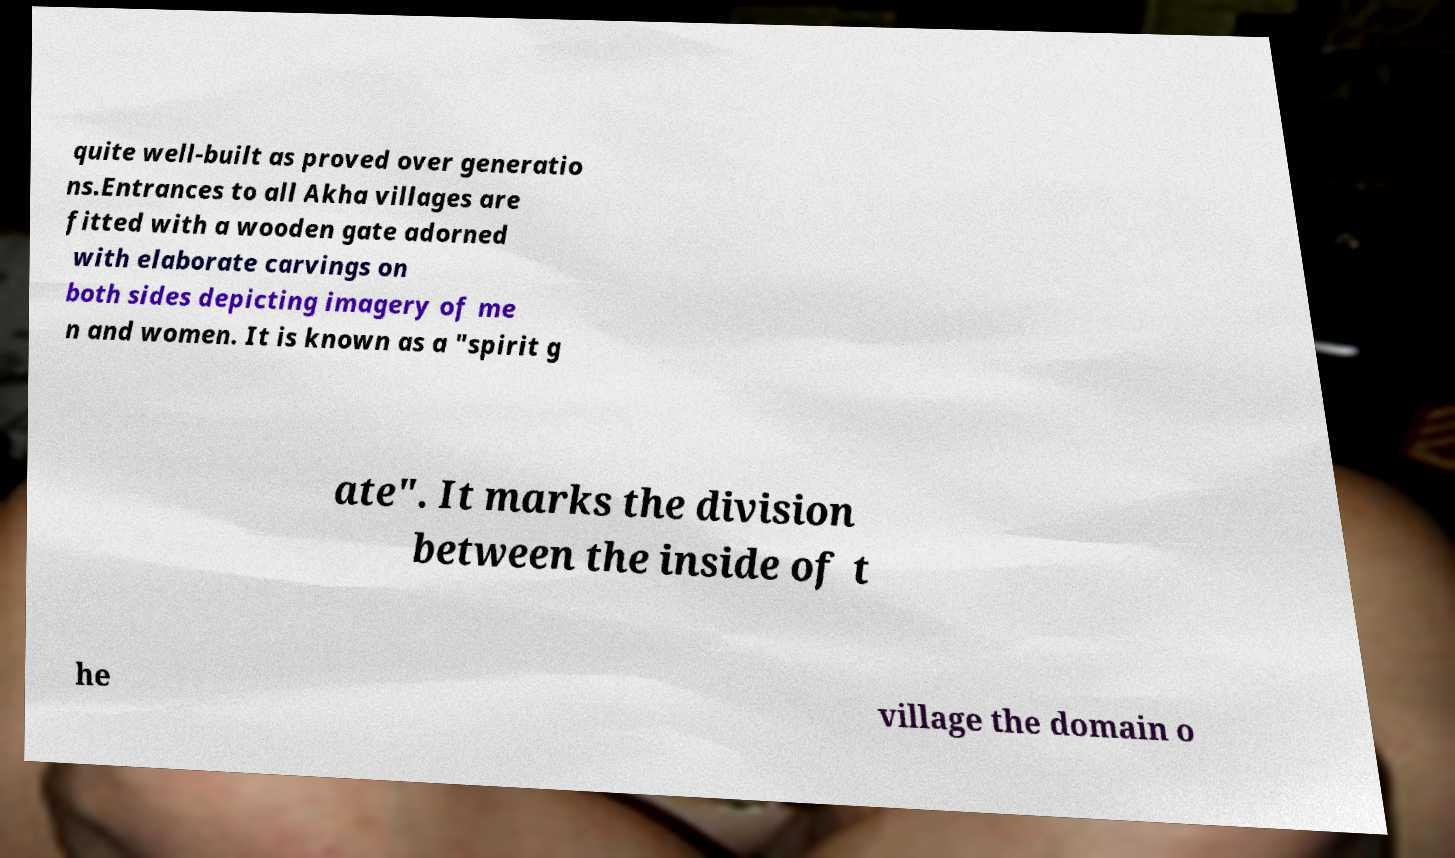Please identify and transcribe the text found in this image. quite well-built as proved over generatio ns.Entrances to all Akha villages are fitted with a wooden gate adorned with elaborate carvings on both sides depicting imagery of me n and women. It is known as a "spirit g ate". It marks the division between the inside of t he village the domain o 